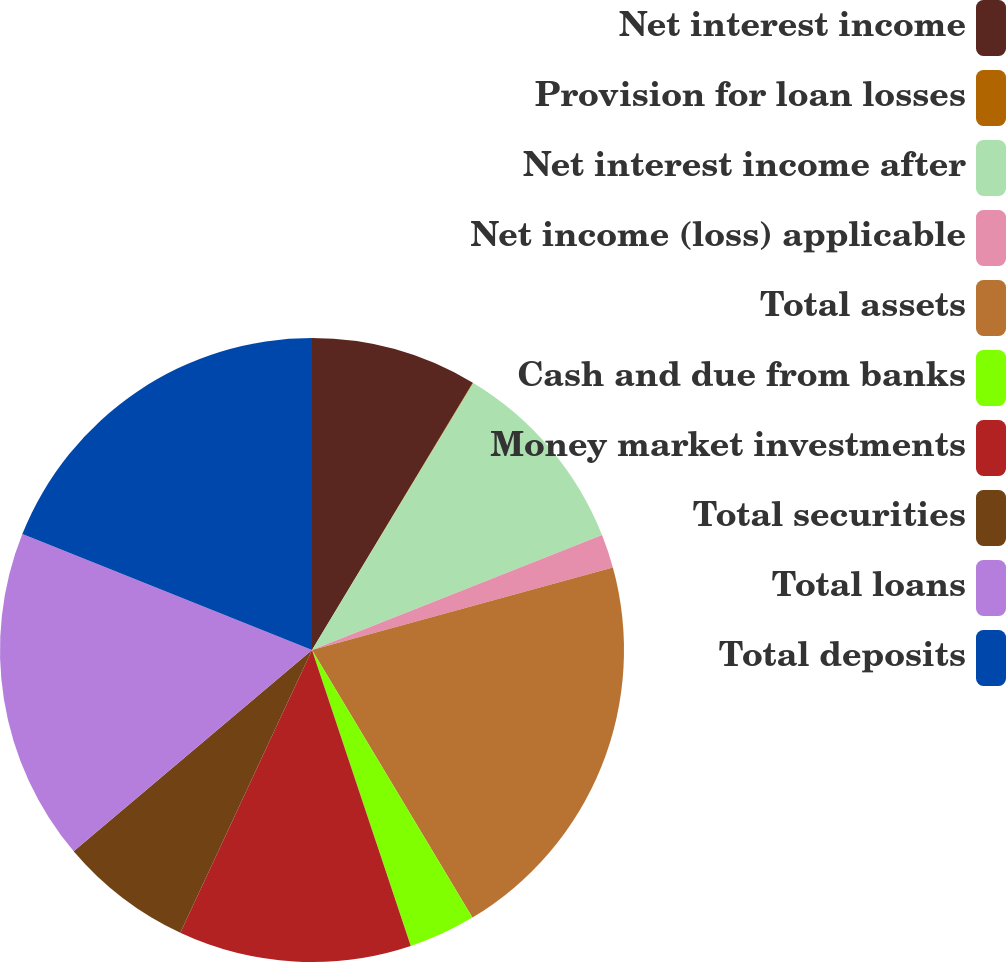Convert chart. <chart><loc_0><loc_0><loc_500><loc_500><pie_chart><fcel>Net interest income<fcel>Provision for loan losses<fcel>Net interest income after<fcel>Net income (loss) applicable<fcel>Total assets<fcel>Cash and due from banks<fcel>Money market investments<fcel>Total securities<fcel>Total loans<fcel>Total deposits<nl><fcel>8.62%<fcel>0.03%<fcel>10.34%<fcel>1.75%<fcel>20.66%<fcel>3.47%<fcel>12.06%<fcel>6.9%<fcel>17.22%<fcel>18.94%<nl></chart> 